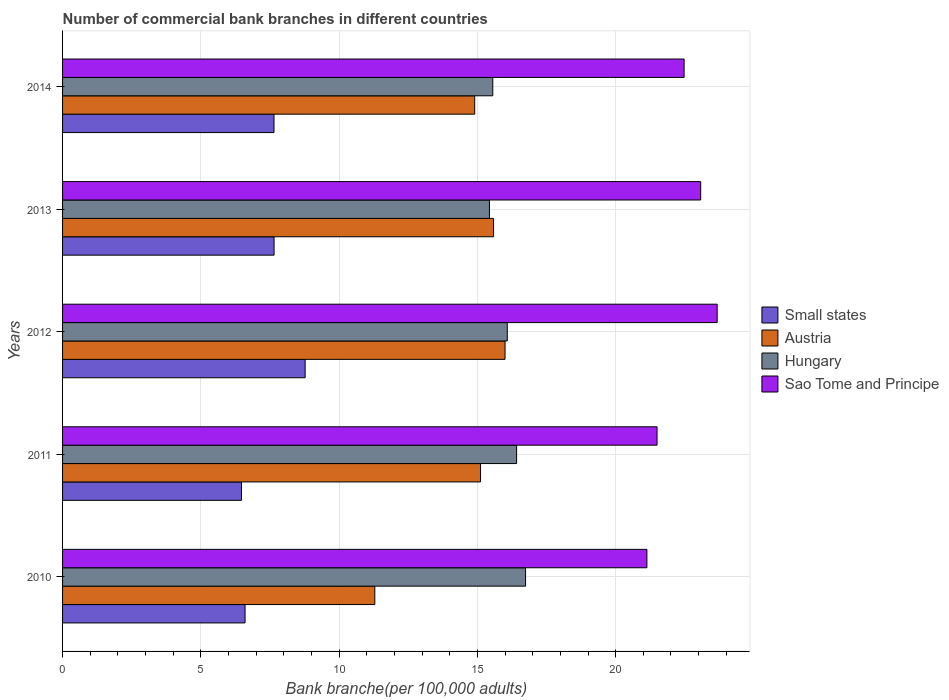How many bars are there on the 4th tick from the top?
Keep it short and to the point. 4. In how many cases, is the number of bars for a given year not equal to the number of legend labels?
Provide a succinct answer. 0. What is the number of commercial bank branches in Sao Tome and Principe in 2014?
Give a very brief answer. 22.48. Across all years, what is the maximum number of commercial bank branches in Hungary?
Offer a very short reply. 16.74. Across all years, what is the minimum number of commercial bank branches in Austria?
Make the answer very short. 11.29. In which year was the number of commercial bank branches in Austria maximum?
Your answer should be very brief. 2012. What is the total number of commercial bank branches in Austria in the graph?
Offer a terse response. 72.89. What is the difference between the number of commercial bank branches in Small states in 2013 and that in 2014?
Provide a short and direct response. 0. What is the difference between the number of commercial bank branches in Hungary in 2011 and the number of commercial bank branches in Austria in 2014?
Provide a short and direct response. 1.52. What is the average number of commercial bank branches in Small states per year?
Your answer should be very brief. 7.43. In the year 2013, what is the difference between the number of commercial bank branches in Small states and number of commercial bank branches in Austria?
Provide a short and direct response. -7.94. What is the ratio of the number of commercial bank branches in Small states in 2012 to that in 2014?
Make the answer very short. 1.15. Is the difference between the number of commercial bank branches in Small states in 2010 and 2011 greater than the difference between the number of commercial bank branches in Austria in 2010 and 2011?
Give a very brief answer. Yes. What is the difference between the highest and the second highest number of commercial bank branches in Small states?
Keep it short and to the point. 1.12. What is the difference between the highest and the lowest number of commercial bank branches in Sao Tome and Principe?
Your answer should be compact. 2.54. In how many years, is the number of commercial bank branches in Austria greater than the average number of commercial bank branches in Austria taken over all years?
Provide a succinct answer. 4. Is the sum of the number of commercial bank branches in Sao Tome and Principe in 2011 and 2012 greater than the maximum number of commercial bank branches in Austria across all years?
Provide a succinct answer. Yes. What does the 1st bar from the top in 2011 represents?
Keep it short and to the point. Sao Tome and Principe. What does the 3rd bar from the bottom in 2010 represents?
Your answer should be very brief. Hungary. Is it the case that in every year, the sum of the number of commercial bank branches in Sao Tome and Principe and number of commercial bank branches in Small states is greater than the number of commercial bank branches in Austria?
Keep it short and to the point. Yes. Are all the bars in the graph horizontal?
Make the answer very short. Yes. What is the difference between two consecutive major ticks on the X-axis?
Give a very brief answer. 5. Does the graph contain any zero values?
Give a very brief answer. No. Does the graph contain grids?
Make the answer very short. Yes. Where does the legend appear in the graph?
Ensure brevity in your answer.  Center right. How many legend labels are there?
Provide a succinct answer. 4. What is the title of the graph?
Offer a very short reply. Number of commercial bank branches in different countries. Does "Switzerland" appear as one of the legend labels in the graph?
Make the answer very short. No. What is the label or title of the X-axis?
Provide a succinct answer. Bank branche(per 100,0 adults). What is the Bank branche(per 100,000 adults) of Small states in 2010?
Your response must be concise. 6.6. What is the Bank branche(per 100,000 adults) in Austria in 2010?
Provide a succinct answer. 11.29. What is the Bank branche(per 100,000 adults) in Hungary in 2010?
Provide a succinct answer. 16.74. What is the Bank branche(per 100,000 adults) in Sao Tome and Principe in 2010?
Make the answer very short. 21.13. What is the Bank branche(per 100,000 adults) in Small states in 2011?
Your answer should be compact. 6.47. What is the Bank branche(per 100,000 adults) in Austria in 2011?
Your answer should be compact. 15.11. What is the Bank branche(per 100,000 adults) in Hungary in 2011?
Give a very brief answer. 16.42. What is the Bank branche(per 100,000 adults) of Sao Tome and Principe in 2011?
Your answer should be very brief. 21.5. What is the Bank branche(per 100,000 adults) in Small states in 2012?
Provide a succinct answer. 8.77. What is the Bank branche(per 100,000 adults) of Austria in 2012?
Your response must be concise. 16. What is the Bank branche(per 100,000 adults) of Hungary in 2012?
Offer a very short reply. 16.08. What is the Bank branche(per 100,000 adults) of Sao Tome and Principe in 2012?
Ensure brevity in your answer.  23.67. What is the Bank branche(per 100,000 adults) of Small states in 2013?
Provide a succinct answer. 7.65. What is the Bank branche(per 100,000 adults) in Austria in 2013?
Your answer should be compact. 15.58. What is the Bank branche(per 100,000 adults) of Hungary in 2013?
Give a very brief answer. 15.44. What is the Bank branche(per 100,000 adults) in Sao Tome and Principe in 2013?
Your answer should be compact. 23.07. What is the Bank branche(per 100,000 adults) of Small states in 2014?
Keep it short and to the point. 7.65. What is the Bank branche(per 100,000 adults) of Austria in 2014?
Your response must be concise. 14.9. What is the Bank branche(per 100,000 adults) in Hungary in 2014?
Your response must be concise. 15.56. What is the Bank branche(per 100,000 adults) in Sao Tome and Principe in 2014?
Your answer should be compact. 22.48. Across all years, what is the maximum Bank branche(per 100,000 adults) in Small states?
Keep it short and to the point. 8.77. Across all years, what is the maximum Bank branche(per 100,000 adults) in Austria?
Make the answer very short. 16. Across all years, what is the maximum Bank branche(per 100,000 adults) of Hungary?
Offer a very short reply. 16.74. Across all years, what is the maximum Bank branche(per 100,000 adults) in Sao Tome and Principe?
Give a very brief answer. 23.67. Across all years, what is the minimum Bank branche(per 100,000 adults) in Small states?
Provide a short and direct response. 6.47. Across all years, what is the minimum Bank branche(per 100,000 adults) of Austria?
Provide a succinct answer. 11.29. Across all years, what is the minimum Bank branche(per 100,000 adults) in Hungary?
Provide a succinct answer. 15.44. Across all years, what is the minimum Bank branche(per 100,000 adults) of Sao Tome and Principe?
Give a very brief answer. 21.13. What is the total Bank branche(per 100,000 adults) in Small states in the graph?
Offer a terse response. 37.13. What is the total Bank branche(per 100,000 adults) of Austria in the graph?
Offer a very short reply. 72.89. What is the total Bank branche(per 100,000 adults) of Hungary in the graph?
Offer a terse response. 80.23. What is the total Bank branche(per 100,000 adults) of Sao Tome and Principe in the graph?
Your answer should be very brief. 111.84. What is the difference between the Bank branche(per 100,000 adults) in Small states in 2010 and that in 2011?
Ensure brevity in your answer.  0.13. What is the difference between the Bank branche(per 100,000 adults) of Austria in 2010 and that in 2011?
Offer a very short reply. -3.82. What is the difference between the Bank branche(per 100,000 adults) in Hungary in 2010 and that in 2011?
Ensure brevity in your answer.  0.32. What is the difference between the Bank branche(per 100,000 adults) of Sao Tome and Principe in 2010 and that in 2011?
Ensure brevity in your answer.  -0.37. What is the difference between the Bank branche(per 100,000 adults) of Small states in 2010 and that in 2012?
Make the answer very short. -2.17. What is the difference between the Bank branche(per 100,000 adults) in Austria in 2010 and that in 2012?
Give a very brief answer. -4.71. What is the difference between the Bank branche(per 100,000 adults) in Hungary in 2010 and that in 2012?
Ensure brevity in your answer.  0.66. What is the difference between the Bank branche(per 100,000 adults) in Sao Tome and Principe in 2010 and that in 2012?
Offer a very short reply. -2.54. What is the difference between the Bank branche(per 100,000 adults) of Small states in 2010 and that in 2013?
Ensure brevity in your answer.  -1.05. What is the difference between the Bank branche(per 100,000 adults) in Austria in 2010 and that in 2013?
Your answer should be very brief. -4.29. What is the difference between the Bank branche(per 100,000 adults) in Hungary in 2010 and that in 2013?
Your answer should be compact. 1.31. What is the difference between the Bank branche(per 100,000 adults) of Sao Tome and Principe in 2010 and that in 2013?
Provide a succinct answer. -1.94. What is the difference between the Bank branche(per 100,000 adults) in Small states in 2010 and that in 2014?
Provide a short and direct response. -1.05. What is the difference between the Bank branche(per 100,000 adults) of Austria in 2010 and that in 2014?
Provide a short and direct response. -3.61. What is the difference between the Bank branche(per 100,000 adults) in Hungary in 2010 and that in 2014?
Offer a very short reply. 1.19. What is the difference between the Bank branche(per 100,000 adults) of Sao Tome and Principe in 2010 and that in 2014?
Your answer should be very brief. -1.35. What is the difference between the Bank branche(per 100,000 adults) of Small states in 2011 and that in 2012?
Offer a very short reply. -2.3. What is the difference between the Bank branche(per 100,000 adults) in Austria in 2011 and that in 2012?
Offer a terse response. -0.89. What is the difference between the Bank branche(per 100,000 adults) of Hungary in 2011 and that in 2012?
Make the answer very short. 0.34. What is the difference between the Bank branche(per 100,000 adults) in Sao Tome and Principe in 2011 and that in 2012?
Give a very brief answer. -2.17. What is the difference between the Bank branche(per 100,000 adults) of Small states in 2011 and that in 2013?
Make the answer very short. -1.18. What is the difference between the Bank branche(per 100,000 adults) in Austria in 2011 and that in 2013?
Offer a terse response. -0.47. What is the difference between the Bank branche(per 100,000 adults) of Hungary in 2011 and that in 2013?
Provide a short and direct response. 0.98. What is the difference between the Bank branche(per 100,000 adults) of Sao Tome and Principe in 2011 and that in 2013?
Give a very brief answer. -1.58. What is the difference between the Bank branche(per 100,000 adults) of Small states in 2011 and that in 2014?
Ensure brevity in your answer.  -1.18. What is the difference between the Bank branche(per 100,000 adults) of Austria in 2011 and that in 2014?
Offer a very short reply. 0.21. What is the difference between the Bank branche(per 100,000 adults) in Hungary in 2011 and that in 2014?
Provide a succinct answer. 0.86. What is the difference between the Bank branche(per 100,000 adults) of Sao Tome and Principe in 2011 and that in 2014?
Make the answer very short. -0.98. What is the difference between the Bank branche(per 100,000 adults) in Small states in 2012 and that in 2013?
Your response must be concise. 1.12. What is the difference between the Bank branche(per 100,000 adults) of Austria in 2012 and that in 2013?
Your answer should be compact. 0.42. What is the difference between the Bank branche(per 100,000 adults) in Hungary in 2012 and that in 2013?
Offer a very short reply. 0.65. What is the difference between the Bank branche(per 100,000 adults) of Sao Tome and Principe in 2012 and that in 2013?
Provide a succinct answer. 0.6. What is the difference between the Bank branche(per 100,000 adults) of Small states in 2012 and that in 2014?
Your answer should be compact. 1.13. What is the difference between the Bank branche(per 100,000 adults) of Austria in 2012 and that in 2014?
Make the answer very short. 1.1. What is the difference between the Bank branche(per 100,000 adults) of Hungary in 2012 and that in 2014?
Your answer should be very brief. 0.52. What is the difference between the Bank branche(per 100,000 adults) of Sao Tome and Principe in 2012 and that in 2014?
Offer a very short reply. 1.2. What is the difference between the Bank branche(per 100,000 adults) in Small states in 2013 and that in 2014?
Ensure brevity in your answer.  0. What is the difference between the Bank branche(per 100,000 adults) in Austria in 2013 and that in 2014?
Ensure brevity in your answer.  0.68. What is the difference between the Bank branche(per 100,000 adults) of Hungary in 2013 and that in 2014?
Offer a terse response. -0.12. What is the difference between the Bank branche(per 100,000 adults) of Sao Tome and Principe in 2013 and that in 2014?
Your response must be concise. 0.6. What is the difference between the Bank branche(per 100,000 adults) in Small states in 2010 and the Bank branche(per 100,000 adults) in Austria in 2011?
Keep it short and to the point. -8.51. What is the difference between the Bank branche(per 100,000 adults) of Small states in 2010 and the Bank branche(per 100,000 adults) of Hungary in 2011?
Provide a short and direct response. -9.82. What is the difference between the Bank branche(per 100,000 adults) in Small states in 2010 and the Bank branche(per 100,000 adults) in Sao Tome and Principe in 2011?
Your response must be concise. -14.9. What is the difference between the Bank branche(per 100,000 adults) of Austria in 2010 and the Bank branche(per 100,000 adults) of Hungary in 2011?
Your answer should be compact. -5.13. What is the difference between the Bank branche(per 100,000 adults) in Austria in 2010 and the Bank branche(per 100,000 adults) in Sao Tome and Principe in 2011?
Keep it short and to the point. -10.21. What is the difference between the Bank branche(per 100,000 adults) of Hungary in 2010 and the Bank branche(per 100,000 adults) of Sao Tome and Principe in 2011?
Your answer should be compact. -4.75. What is the difference between the Bank branche(per 100,000 adults) of Small states in 2010 and the Bank branche(per 100,000 adults) of Austria in 2012?
Your response must be concise. -9.4. What is the difference between the Bank branche(per 100,000 adults) of Small states in 2010 and the Bank branche(per 100,000 adults) of Hungary in 2012?
Keep it short and to the point. -9.48. What is the difference between the Bank branche(per 100,000 adults) in Small states in 2010 and the Bank branche(per 100,000 adults) in Sao Tome and Principe in 2012?
Ensure brevity in your answer.  -17.07. What is the difference between the Bank branche(per 100,000 adults) in Austria in 2010 and the Bank branche(per 100,000 adults) in Hungary in 2012?
Keep it short and to the point. -4.79. What is the difference between the Bank branche(per 100,000 adults) of Austria in 2010 and the Bank branche(per 100,000 adults) of Sao Tome and Principe in 2012?
Give a very brief answer. -12.38. What is the difference between the Bank branche(per 100,000 adults) in Hungary in 2010 and the Bank branche(per 100,000 adults) in Sao Tome and Principe in 2012?
Make the answer very short. -6.93. What is the difference between the Bank branche(per 100,000 adults) of Small states in 2010 and the Bank branche(per 100,000 adults) of Austria in 2013?
Your response must be concise. -8.99. What is the difference between the Bank branche(per 100,000 adults) in Small states in 2010 and the Bank branche(per 100,000 adults) in Hungary in 2013?
Ensure brevity in your answer.  -8.84. What is the difference between the Bank branche(per 100,000 adults) of Small states in 2010 and the Bank branche(per 100,000 adults) of Sao Tome and Principe in 2013?
Keep it short and to the point. -16.48. What is the difference between the Bank branche(per 100,000 adults) in Austria in 2010 and the Bank branche(per 100,000 adults) in Hungary in 2013?
Your response must be concise. -4.14. What is the difference between the Bank branche(per 100,000 adults) in Austria in 2010 and the Bank branche(per 100,000 adults) in Sao Tome and Principe in 2013?
Keep it short and to the point. -11.78. What is the difference between the Bank branche(per 100,000 adults) in Hungary in 2010 and the Bank branche(per 100,000 adults) in Sao Tome and Principe in 2013?
Make the answer very short. -6.33. What is the difference between the Bank branche(per 100,000 adults) of Small states in 2010 and the Bank branche(per 100,000 adults) of Austria in 2014?
Provide a succinct answer. -8.3. What is the difference between the Bank branche(per 100,000 adults) in Small states in 2010 and the Bank branche(per 100,000 adults) in Hungary in 2014?
Offer a terse response. -8.96. What is the difference between the Bank branche(per 100,000 adults) of Small states in 2010 and the Bank branche(per 100,000 adults) of Sao Tome and Principe in 2014?
Your answer should be compact. -15.88. What is the difference between the Bank branche(per 100,000 adults) in Austria in 2010 and the Bank branche(per 100,000 adults) in Hungary in 2014?
Your response must be concise. -4.27. What is the difference between the Bank branche(per 100,000 adults) of Austria in 2010 and the Bank branche(per 100,000 adults) of Sao Tome and Principe in 2014?
Provide a succinct answer. -11.18. What is the difference between the Bank branche(per 100,000 adults) in Hungary in 2010 and the Bank branche(per 100,000 adults) in Sao Tome and Principe in 2014?
Ensure brevity in your answer.  -5.73. What is the difference between the Bank branche(per 100,000 adults) in Small states in 2011 and the Bank branche(per 100,000 adults) in Austria in 2012?
Your response must be concise. -9.53. What is the difference between the Bank branche(per 100,000 adults) of Small states in 2011 and the Bank branche(per 100,000 adults) of Hungary in 2012?
Provide a succinct answer. -9.61. What is the difference between the Bank branche(per 100,000 adults) of Small states in 2011 and the Bank branche(per 100,000 adults) of Sao Tome and Principe in 2012?
Provide a succinct answer. -17.2. What is the difference between the Bank branche(per 100,000 adults) of Austria in 2011 and the Bank branche(per 100,000 adults) of Hungary in 2012?
Offer a terse response. -0.97. What is the difference between the Bank branche(per 100,000 adults) in Austria in 2011 and the Bank branche(per 100,000 adults) in Sao Tome and Principe in 2012?
Your response must be concise. -8.56. What is the difference between the Bank branche(per 100,000 adults) of Hungary in 2011 and the Bank branche(per 100,000 adults) of Sao Tome and Principe in 2012?
Your answer should be very brief. -7.25. What is the difference between the Bank branche(per 100,000 adults) in Small states in 2011 and the Bank branche(per 100,000 adults) in Austria in 2013?
Ensure brevity in your answer.  -9.11. What is the difference between the Bank branche(per 100,000 adults) of Small states in 2011 and the Bank branche(per 100,000 adults) of Hungary in 2013?
Provide a succinct answer. -8.97. What is the difference between the Bank branche(per 100,000 adults) of Small states in 2011 and the Bank branche(per 100,000 adults) of Sao Tome and Principe in 2013?
Your answer should be very brief. -16.6. What is the difference between the Bank branche(per 100,000 adults) of Austria in 2011 and the Bank branche(per 100,000 adults) of Hungary in 2013?
Your answer should be compact. -0.32. What is the difference between the Bank branche(per 100,000 adults) of Austria in 2011 and the Bank branche(per 100,000 adults) of Sao Tome and Principe in 2013?
Provide a short and direct response. -7.96. What is the difference between the Bank branche(per 100,000 adults) of Hungary in 2011 and the Bank branche(per 100,000 adults) of Sao Tome and Principe in 2013?
Provide a short and direct response. -6.66. What is the difference between the Bank branche(per 100,000 adults) in Small states in 2011 and the Bank branche(per 100,000 adults) in Austria in 2014?
Offer a terse response. -8.43. What is the difference between the Bank branche(per 100,000 adults) of Small states in 2011 and the Bank branche(per 100,000 adults) of Hungary in 2014?
Provide a short and direct response. -9.09. What is the difference between the Bank branche(per 100,000 adults) of Small states in 2011 and the Bank branche(per 100,000 adults) of Sao Tome and Principe in 2014?
Your answer should be compact. -16. What is the difference between the Bank branche(per 100,000 adults) in Austria in 2011 and the Bank branche(per 100,000 adults) in Hungary in 2014?
Give a very brief answer. -0.44. What is the difference between the Bank branche(per 100,000 adults) in Austria in 2011 and the Bank branche(per 100,000 adults) in Sao Tome and Principe in 2014?
Make the answer very short. -7.36. What is the difference between the Bank branche(per 100,000 adults) of Hungary in 2011 and the Bank branche(per 100,000 adults) of Sao Tome and Principe in 2014?
Give a very brief answer. -6.06. What is the difference between the Bank branche(per 100,000 adults) of Small states in 2012 and the Bank branche(per 100,000 adults) of Austria in 2013?
Ensure brevity in your answer.  -6.81. What is the difference between the Bank branche(per 100,000 adults) in Small states in 2012 and the Bank branche(per 100,000 adults) in Hungary in 2013?
Provide a succinct answer. -6.66. What is the difference between the Bank branche(per 100,000 adults) of Small states in 2012 and the Bank branche(per 100,000 adults) of Sao Tome and Principe in 2013?
Provide a succinct answer. -14.3. What is the difference between the Bank branche(per 100,000 adults) in Austria in 2012 and the Bank branche(per 100,000 adults) in Hungary in 2013?
Your response must be concise. 0.56. What is the difference between the Bank branche(per 100,000 adults) in Austria in 2012 and the Bank branche(per 100,000 adults) in Sao Tome and Principe in 2013?
Offer a terse response. -7.07. What is the difference between the Bank branche(per 100,000 adults) of Hungary in 2012 and the Bank branche(per 100,000 adults) of Sao Tome and Principe in 2013?
Make the answer very short. -6.99. What is the difference between the Bank branche(per 100,000 adults) of Small states in 2012 and the Bank branche(per 100,000 adults) of Austria in 2014?
Provide a short and direct response. -6.13. What is the difference between the Bank branche(per 100,000 adults) of Small states in 2012 and the Bank branche(per 100,000 adults) of Hungary in 2014?
Your answer should be very brief. -6.79. What is the difference between the Bank branche(per 100,000 adults) of Small states in 2012 and the Bank branche(per 100,000 adults) of Sao Tome and Principe in 2014?
Provide a short and direct response. -13.7. What is the difference between the Bank branche(per 100,000 adults) of Austria in 2012 and the Bank branche(per 100,000 adults) of Hungary in 2014?
Offer a terse response. 0.44. What is the difference between the Bank branche(per 100,000 adults) of Austria in 2012 and the Bank branche(per 100,000 adults) of Sao Tome and Principe in 2014?
Make the answer very short. -6.48. What is the difference between the Bank branche(per 100,000 adults) in Hungary in 2012 and the Bank branche(per 100,000 adults) in Sao Tome and Principe in 2014?
Ensure brevity in your answer.  -6.39. What is the difference between the Bank branche(per 100,000 adults) in Small states in 2013 and the Bank branche(per 100,000 adults) in Austria in 2014?
Your response must be concise. -7.25. What is the difference between the Bank branche(per 100,000 adults) in Small states in 2013 and the Bank branche(per 100,000 adults) in Hungary in 2014?
Ensure brevity in your answer.  -7.91. What is the difference between the Bank branche(per 100,000 adults) in Small states in 2013 and the Bank branche(per 100,000 adults) in Sao Tome and Principe in 2014?
Give a very brief answer. -14.83. What is the difference between the Bank branche(per 100,000 adults) of Austria in 2013 and the Bank branche(per 100,000 adults) of Hungary in 2014?
Give a very brief answer. 0.03. What is the difference between the Bank branche(per 100,000 adults) of Austria in 2013 and the Bank branche(per 100,000 adults) of Sao Tome and Principe in 2014?
Offer a very short reply. -6.89. What is the difference between the Bank branche(per 100,000 adults) in Hungary in 2013 and the Bank branche(per 100,000 adults) in Sao Tome and Principe in 2014?
Make the answer very short. -7.04. What is the average Bank branche(per 100,000 adults) in Small states per year?
Keep it short and to the point. 7.43. What is the average Bank branche(per 100,000 adults) of Austria per year?
Your answer should be compact. 14.58. What is the average Bank branche(per 100,000 adults) of Hungary per year?
Give a very brief answer. 16.05. What is the average Bank branche(per 100,000 adults) of Sao Tome and Principe per year?
Provide a succinct answer. 22.37. In the year 2010, what is the difference between the Bank branche(per 100,000 adults) of Small states and Bank branche(per 100,000 adults) of Austria?
Your answer should be very brief. -4.69. In the year 2010, what is the difference between the Bank branche(per 100,000 adults) of Small states and Bank branche(per 100,000 adults) of Hungary?
Ensure brevity in your answer.  -10.14. In the year 2010, what is the difference between the Bank branche(per 100,000 adults) in Small states and Bank branche(per 100,000 adults) in Sao Tome and Principe?
Offer a terse response. -14.53. In the year 2010, what is the difference between the Bank branche(per 100,000 adults) of Austria and Bank branche(per 100,000 adults) of Hungary?
Provide a short and direct response. -5.45. In the year 2010, what is the difference between the Bank branche(per 100,000 adults) of Austria and Bank branche(per 100,000 adults) of Sao Tome and Principe?
Keep it short and to the point. -9.84. In the year 2010, what is the difference between the Bank branche(per 100,000 adults) in Hungary and Bank branche(per 100,000 adults) in Sao Tome and Principe?
Offer a terse response. -4.39. In the year 2011, what is the difference between the Bank branche(per 100,000 adults) in Small states and Bank branche(per 100,000 adults) in Austria?
Give a very brief answer. -8.64. In the year 2011, what is the difference between the Bank branche(per 100,000 adults) of Small states and Bank branche(per 100,000 adults) of Hungary?
Provide a short and direct response. -9.95. In the year 2011, what is the difference between the Bank branche(per 100,000 adults) in Small states and Bank branche(per 100,000 adults) in Sao Tome and Principe?
Offer a terse response. -15.03. In the year 2011, what is the difference between the Bank branche(per 100,000 adults) in Austria and Bank branche(per 100,000 adults) in Hungary?
Make the answer very short. -1.3. In the year 2011, what is the difference between the Bank branche(per 100,000 adults) in Austria and Bank branche(per 100,000 adults) in Sao Tome and Principe?
Your response must be concise. -6.38. In the year 2011, what is the difference between the Bank branche(per 100,000 adults) of Hungary and Bank branche(per 100,000 adults) of Sao Tome and Principe?
Provide a short and direct response. -5.08. In the year 2012, what is the difference between the Bank branche(per 100,000 adults) in Small states and Bank branche(per 100,000 adults) in Austria?
Offer a very short reply. -7.23. In the year 2012, what is the difference between the Bank branche(per 100,000 adults) of Small states and Bank branche(per 100,000 adults) of Hungary?
Offer a very short reply. -7.31. In the year 2012, what is the difference between the Bank branche(per 100,000 adults) in Small states and Bank branche(per 100,000 adults) in Sao Tome and Principe?
Make the answer very short. -14.9. In the year 2012, what is the difference between the Bank branche(per 100,000 adults) of Austria and Bank branche(per 100,000 adults) of Hungary?
Give a very brief answer. -0.08. In the year 2012, what is the difference between the Bank branche(per 100,000 adults) of Austria and Bank branche(per 100,000 adults) of Sao Tome and Principe?
Your answer should be very brief. -7.67. In the year 2012, what is the difference between the Bank branche(per 100,000 adults) of Hungary and Bank branche(per 100,000 adults) of Sao Tome and Principe?
Ensure brevity in your answer.  -7.59. In the year 2013, what is the difference between the Bank branche(per 100,000 adults) in Small states and Bank branche(per 100,000 adults) in Austria?
Keep it short and to the point. -7.94. In the year 2013, what is the difference between the Bank branche(per 100,000 adults) of Small states and Bank branche(per 100,000 adults) of Hungary?
Your response must be concise. -7.79. In the year 2013, what is the difference between the Bank branche(per 100,000 adults) of Small states and Bank branche(per 100,000 adults) of Sao Tome and Principe?
Keep it short and to the point. -15.43. In the year 2013, what is the difference between the Bank branche(per 100,000 adults) of Austria and Bank branche(per 100,000 adults) of Hungary?
Keep it short and to the point. 0.15. In the year 2013, what is the difference between the Bank branche(per 100,000 adults) of Austria and Bank branche(per 100,000 adults) of Sao Tome and Principe?
Your answer should be compact. -7.49. In the year 2013, what is the difference between the Bank branche(per 100,000 adults) of Hungary and Bank branche(per 100,000 adults) of Sao Tome and Principe?
Give a very brief answer. -7.64. In the year 2014, what is the difference between the Bank branche(per 100,000 adults) in Small states and Bank branche(per 100,000 adults) in Austria?
Give a very brief answer. -7.26. In the year 2014, what is the difference between the Bank branche(per 100,000 adults) in Small states and Bank branche(per 100,000 adults) in Hungary?
Provide a succinct answer. -7.91. In the year 2014, what is the difference between the Bank branche(per 100,000 adults) of Small states and Bank branche(per 100,000 adults) of Sao Tome and Principe?
Make the answer very short. -14.83. In the year 2014, what is the difference between the Bank branche(per 100,000 adults) in Austria and Bank branche(per 100,000 adults) in Hungary?
Offer a terse response. -0.65. In the year 2014, what is the difference between the Bank branche(per 100,000 adults) in Austria and Bank branche(per 100,000 adults) in Sao Tome and Principe?
Your response must be concise. -7.57. In the year 2014, what is the difference between the Bank branche(per 100,000 adults) in Hungary and Bank branche(per 100,000 adults) in Sao Tome and Principe?
Your response must be concise. -6.92. What is the ratio of the Bank branche(per 100,000 adults) of Small states in 2010 to that in 2011?
Offer a very short reply. 1.02. What is the ratio of the Bank branche(per 100,000 adults) in Austria in 2010 to that in 2011?
Your answer should be very brief. 0.75. What is the ratio of the Bank branche(per 100,000 adults) of Hungary in 2010 to that in 2011?
Your answer should be very brief. 1.02. What is the ratio of the Bank branche(per 100,000 adults) in Sao Tome and Principe in 2010 to that in 2011?
Make the answer very short. 0.98. What is the ratio of the Bank branche(per 100,000 adults) of Small states in 2010 to that in 2012?
Provide a short and direct response. 0.75. What is the ratio of the Bank branche(per 100,000 adults) in Austria in 2010 to that in 2012?
Offer a very short reply. 0.71. What is the ratio of the Bank branche(per 100,000 adults) in Hungary in 2010 to that in 2012?
Give a very brief answer. 1.04. What is the ratio of the Bank branche(per 100,000 adults) of Sao Tome and Principe in 2010 to that in 2012?
Provide a succinct answer. 0.89. What is the ratio of the Bank branche(per 100,000 adults) in Small states in 2010 to that in 2013?
Give a very brief answer. 0.86. What is the ratio of the Bank branche(per 100,000 adults) in Austria in 2010 to that in 2013?
Provide a succinct answer. 0.72. What is the ratio of the Bank branche(per 100,000 adults) in Hungary in 2010 to that in 2013?
Offer a terse response. 1.08. What is the ratio of the Bank branche(per 100,000 adults) of Sao Tome and Principe in 2010 to that in 2013?
Provide a succinct answer. 0.92. What is the ratio of the Bank branche(per 100,000 adults) in Small states in 2010 to that in 2014?
Your answer should be very brief. 0.86. What is the ratio of the Bank branche(per 100,000 adults) of Austria in 2010 to that in 2014?
Keep it short and to the point. 0.76. What is the ratio of the Bank branche(per 100,000 adults) in Hungary in 2010 to that in 2014?
Provide a succinct answer. 1.08. What is the ratio of the Bank branche(per 100,000 adults) of Sao Tome and Principe in 2010 to that in 2014?
Offer a terse response. 0.94. What is the ratio of the Bank branche(per 100,000 adults) in Small states in 2011 to that in 2012?
Your response must be concise. 0.74. What is the ratio of the Bank branche(per 100,000 adults) in Austria in 2011 to that in 2012?
Offer a very short reply. 0.94. What is the ratio of the Bank branche(per 100,000 adults) of Sao Tome and Principe in 2011 to that in 2012?
Provide a short and direct response. 0.91. What is the ratio of the Bank branche(per 100,000 adults) of Small states in 2011 to that in 2013?
Give a very brief answer. 0.85. What is the ratio of the Bank branche(per 100,000 adults) in Austria in 2011 to that in 2013?
Offer a terse response. 0.97. What is the ratio of the Bank branche(per 100,000 adults) in Hungary in 2011 to that in 2013?
Ensure brevity in your answer.  1.06. What is the ratio of the Bank branche(per 100,000 adults) in Sao Tome and Principe in 2011 to that in 2013?
Provide a short and direct response. 0.93. What is the ratio of the Bank branche(per 100,000 adults) in Small states in 2011 to that in 2014?
Offer a terse response. 0.85. What is the ratio of the Bank branche(per 100,000 adults) of Austria in 2011 to that in 2014?
Provide a short and direct response. 1.01. What is the ratio of the Bank branche(per 100,000 adults) in Hungary in 2011 to that in 2014?
Provide a succinct answer. 1.06. What is the ratio of the Bank branche(per 100,000 adults) in Sao Tome and Principe in 2011 to that in 2014?
Provide a short and direct response. 0.96. What is the ratio of the Bank branche(per 100,000 adults) of Small states in 2012 to that in 2013?
Give a very brief answer. 1.15. What is the ratio of the Bank branche(per 100,000 adults) in Austria in 2012 to that in 2013?
Provide a short and direct response. 1.03. What is the ratio of the Bank branche(per 100,000 adults) in Hungary in 2012 to that in 2013?
Offer a terse response. 1.04. What is the ratio of the Bank branche(per 100,000 adults) in Sao Tome and Principe in 2012 to that in 2013?
Ensure brevity in your answer.  1.03. What is the ratio of the Bank branche(per 100,000 adults) in Small states in 2012 to that in 2014?
Your response must be concise. 1.15. What is the ratio of the Bank branche(per 100,000 adults) of Austria in 2012 to that in 2014?
Offer a terse response. 1.07. What is the ratio of the Bank branche(per 100,000 adults) of Hungary in 2012 to that in 2014?
Offer a very short reply. 1.03. What is the ratio of the Bank branche(per 100,000 adults) of Sao Tome and Principe in 2012 to that in 2014?
Provide a succinct answer. 1.05. What is the ratio of the Bank branche(per 100,000 adults) of Austria in 2013 to that in 2014?
Keep it short and to the point. 1.05. What is the ratio of the Bank branche(per 100,000 adults) in Hungary in 2013 to that in 2014?
Your answer should be very brief. 0.99. What is the ratio of the Bank branche(per 100,000 adults) in Sao Tome and Principe in 2013 to that in 2014?
Give a very brief answer. 1.03. What is the difference between the highest and the second highest Bank branche(per 100,000 adults) in Small states?
Ensure brevity in your answer.  1.12. What is the difference between the highest and the second highest Bank branche(per 100,000 adults) of Austria?
Your response must be concise. 0.42. What is the difference between the highest and the second highest Bank branche(per 100,000 adults) in Hungary?
Your answer should be very brief. 0.32. What is the difference between the highest and the second highest Bank branche(per 100,000 adults) of Sao Tome and Principe?
Your answer should be very brief. 0.6. What is the difference between the highest and the lowest Bank branche(per 100,000 adults) of Small states?
Give a very brief answer. 2.3. What is the difference between the highest and the lowest Bank branche(per 100,000 adults) in Austria?
Make the answer very short. 4.71. What is the difference between the highest and the lowest Bank branche(per 100,000 adults) of Hungary?
Offer a terse response. 1.31. What is the difference between the highest and the lowest Bank branche(per 100,000 adults) in Sao Tome and Principe?
Provide a short and direct response. 2.54. 